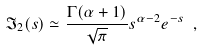<formula> <loc_0><loc_0><loc_500><loc_500>\mathfrak { I } _ { 2 } ( s ) \simeq \frac { \Gamma ( \alpha + 1 ) } { \sqrt { \pi } } s ^ { \alpha - 2 } e ^ { - s } \ ,</formula> 